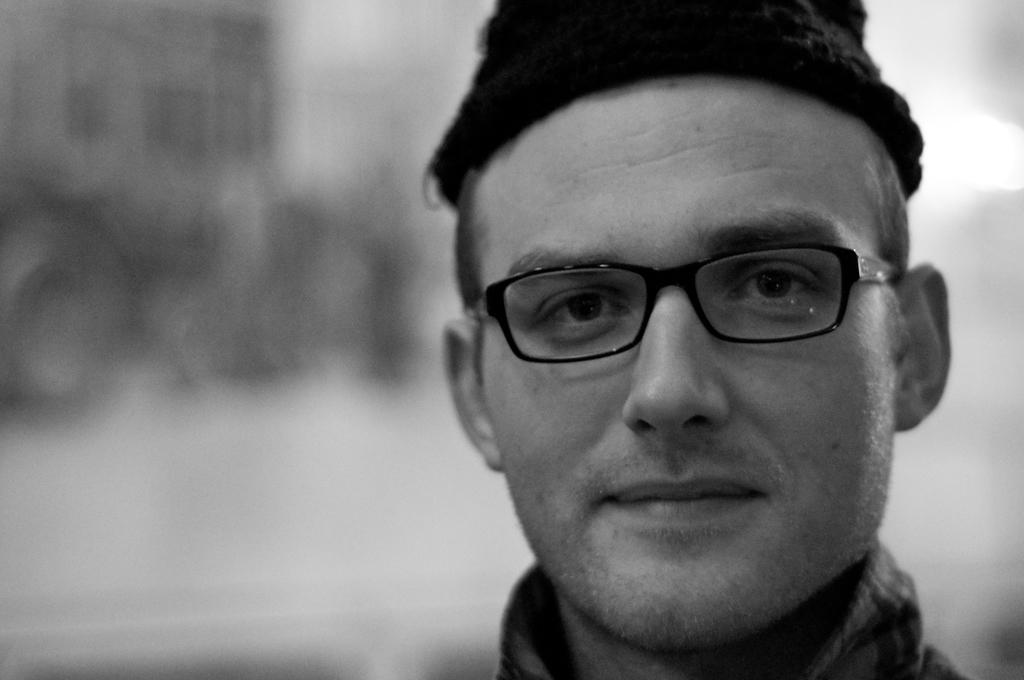What is the main subject of the image? There is a man in the image. What can be observed about the man's appearance? The man is wearing spectacles and a cap. What is the man's facial expression? The man is smiling. Can you describe the background of the image? The background of the image is blurry. What type of door can be seen in the image? There is no door present in the image; it features a man wearing spectacles, a cap, and smiling. How does the dust affect the man's appearance in the image? There is no dust present in the image, so it does not affect the man's appearance. 